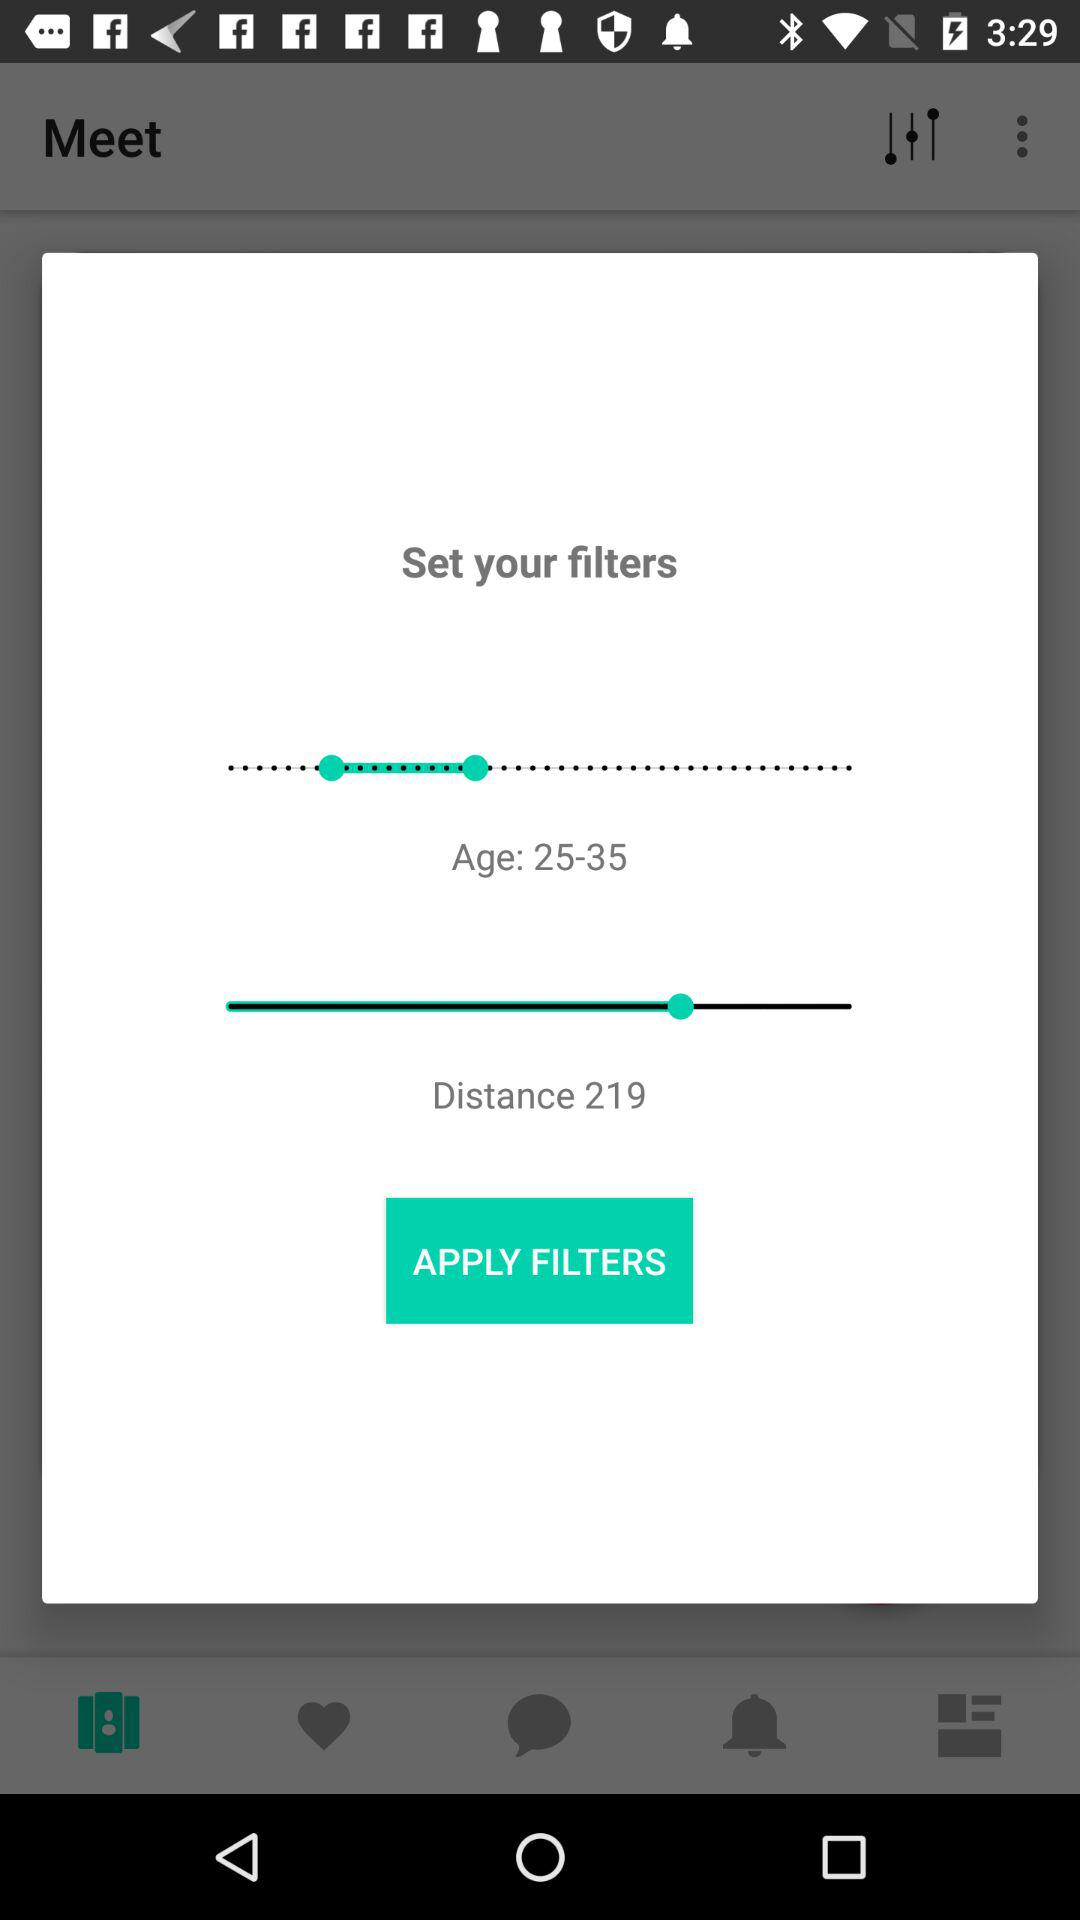What is the set distance? The set distance is 219. 